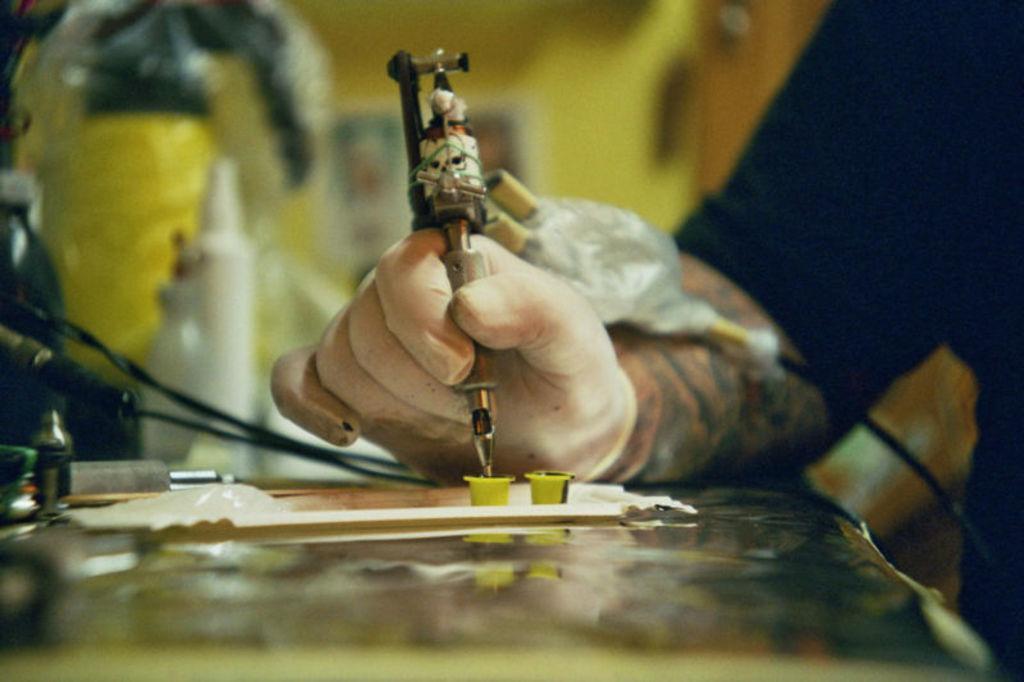How would you summarize this image in a sentence or two? In this image we can see a person's hand holding an object and working on some other object on the table, there we can also see few cables and some other objects on the table. 